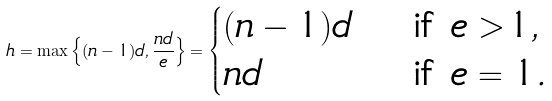<formula> <loc_0><loc_0><loc_500><loc_500>h = \max \left \{ ( n - 1 ) d , \frac { n d } { e } \right \} = \begin{cases} ( n - 1 ) d & \text { if } e > 1 , \\ n d & \text { if } e = 1 . \end{cases}</formula> 